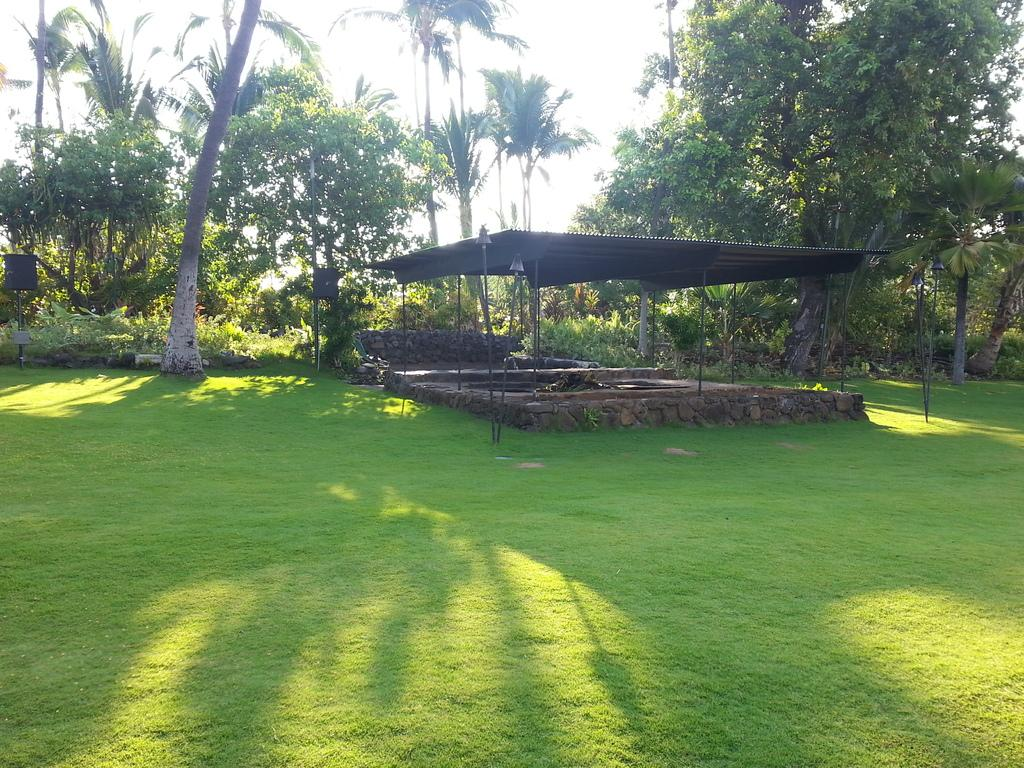What type of structure can be seen in the image? There is a shed in the image. What is located beneath the shed? There is a rock structure on the grass beneath the shed. What can be seen in the background of the image? There are trees and the sky visible in the background of the image. What book is the rabbit reading in the image? There is no rabbit or book present in the image. 